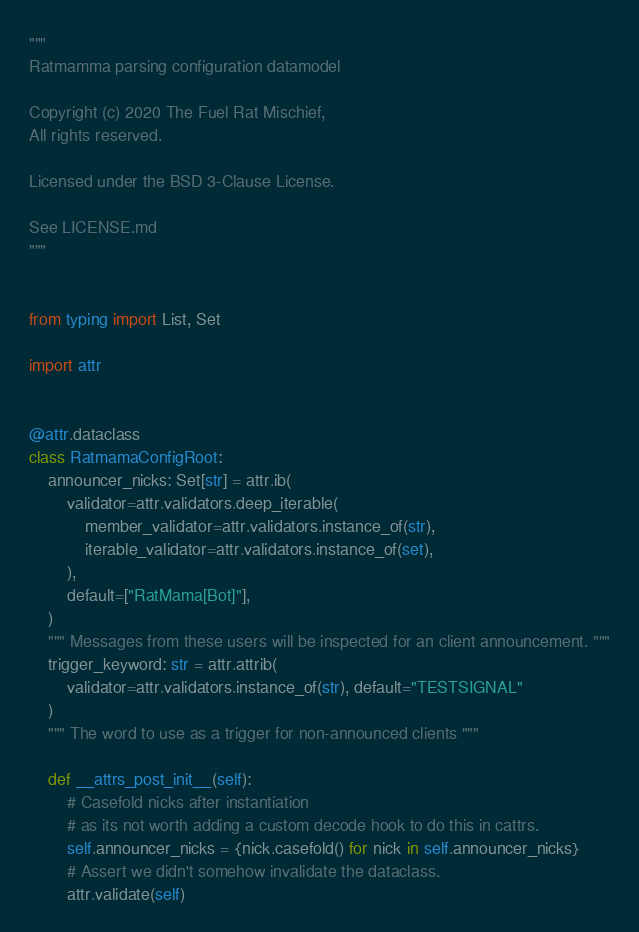<code> <loc_0><loc_0><loc_500><loc_500><_Python_>"""
Ratmamma parsing configuration datamodel

Copyright (c) 2020 The Fuel Rat Mischief,
All rights reserved.

Licensed under the BSD 3-Clause License.

See LICENSE.md
"""


from typing import List, Set

import attr


@attr.dataclass
class RatmamaConfigRoot:
    announcer_nicks: Set[str] = attr.ib(
        validator=attr.validators.deep_iterable(
            member_validator=attr.validators.instance_of(str),
            iterable_validator=attr.validators.instance_of(set),
        ),
        default=["RatMama[Bot]"],
    )
    """ Messages from these users will be inspected for an client announcement. """
    trigger_keyword: str = attr.attrib(
        validator=attr.validators.instance_of(str), default="TESTSIGNAL"
    )
    """ The word to use as a trigger for non-announced clients """

    def __attrs_post_init__(self):
        # Casefold nicks after instantiation
        # as its not worth adding a custom decode hook to do this in cattrs.
        self.announcer_nicks = {nick.casefold() for nick in self.announcer_nicks}
        # Assert we didn't somehow invalidate the dataclass.
        attr.validate(self)
</code> 